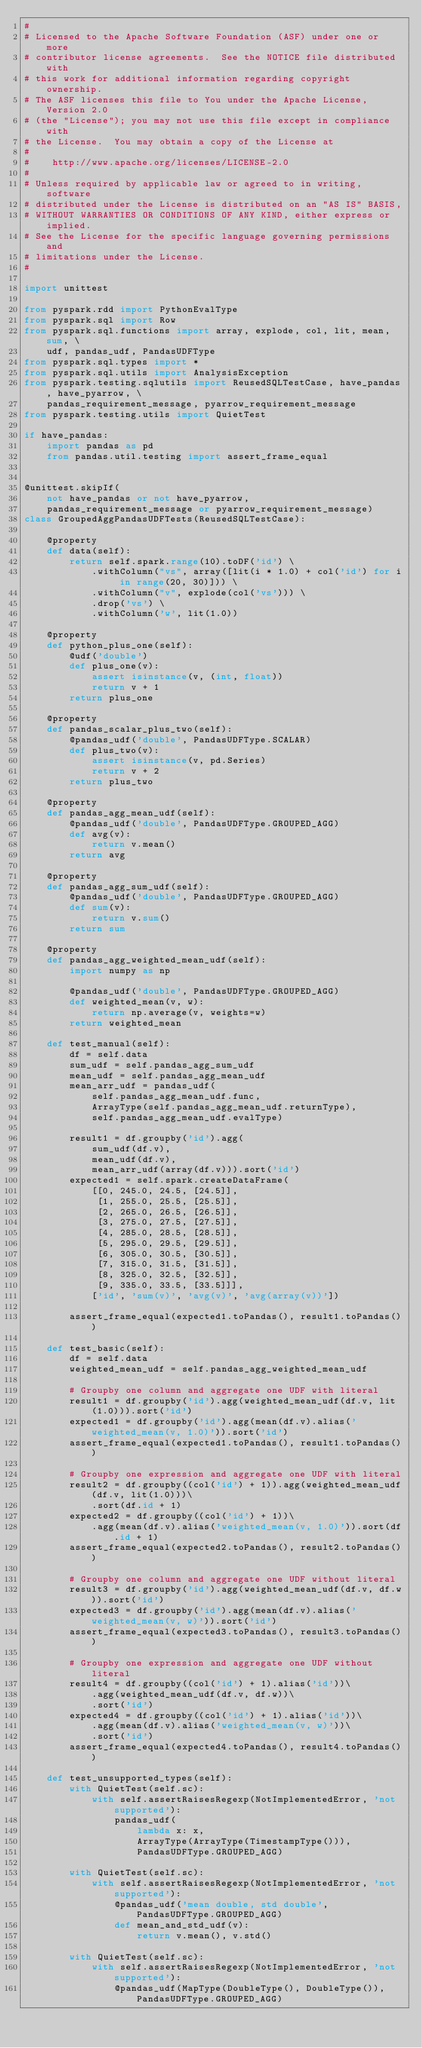Convert code to text. <code><loc_0><loc_0><loc_500><loc_500><_Python_>#
# Licensed to the Apache Software Foundation (ASF) under one or more
# contributor license agreements.  See the NOTICE file distributed with
# this work for additional information regarding copyright ownership.
# The ASF licenses this file to You under the Apache License, Version 2.0
# (the "License"); you may not use this file except in compliance with
# the License.  You may obtain a copy of the License at
#
#    http://www.apache.org/licenses/LICENSE-2.0
#
# Unless required by applicable law or agreed to in writing, software
# distributed under the License is distributed on an "AS IS" BASIS,
# WITHOUT WARRANTIES OR CONDITIONS OF ANY KIND, either express or implied.
# See the License for the specific language governing permissions and
# limitations under the License.
#

import unittest

from pyspark.rdd import PythonEvalType
from pyspark.sql import Row
from pyspark.sql.functions import array, explode, col, lit, mean, sum, \
    udf, pandas_udf, PandasUDFType
from pyspark.sql.types import *
from pyspark.sql.utils import AnalysisException
from pyspark.testing.sqlutils import ReusedSQLTestCase, have_pandas, have_pyarrow, \
    pandas_requirement_message, pyarrow_requirement_message
from pyspark.testing.utils import QuietTest

if have_pandas:
    import pandas as pd
    from pandas.util.testing import assert_frame_equal


@unittest.skipIf(
    not have_pandas or not have_pyarrow,
    pandas_requirement_message or pyarrow_requirement_message)
class GroupedAggPandasUDFTests(ReusedSQLTestCase):

    @property
    def data(self):
        return self.spark.range(10).toDF('id') \
            .withColumn("vs", array([lit(i * 1.0) + col('id') for i in range(20, 30)])) \
            .withColumn("v", explode(col('vs'))) \
            .drop('vs') \
            .withColumn('w', lit(1.0))

    @property
    def python_plus_one(self):
        @udf('double')
        def plus_one(v):
            assert isinstance(v, (int, float))
            return v + 1
        return plus_one

    @property
    def pandas_scalar_plus_two(self):
        @pandas_udf('double', PandasUDFType.SCALAR)
        def plus_two(v):
            assert isinstance(v, pd.Series)
            return v + 2
        return plus_two

    @property
    def pandas_agg_mean_udf(self):
        @pandas_udf('double', PandasUDFType.GROUPED_AGG)
        def avg(v):
            return v.mean()
        return avg

    @property
    def pandas_agg_sum_udf(self):
        @pandas_udf('double', PandasUDFType.GROUPED_AGG)
        def sum(v):
            return v.sum()
        return sum

    @property
    def pandas_agg_weighted_mean_udf(self):
        import numpy as np

        @pandas_udf('double', PandasUDFType.GROUPED_AGG)
        def weighted_mean(v, w):
            return np.average(v, weights=w)
        return weighted_mean

    def test_manual(self):
        df = self.data
        sum_udf = self.pandas_agg_sum_udf
        mean_udf = self.pandas_agg_mean_udf
        mean_arr_udf = pandas_udf(
            self.pandas_agg_mean_udf.func,
            ArrayType(self.pandas_agg_mean_udf.returnType),
            self.pandas_agg_mean_udf.evalType)

        result1 = df.groupby('id').agg(
            sum_udf(df.v),
            mean_udf(df.v),
            mean_arr_udf(array(df.v))).sort('id')
        expected1 = self.spark.createDataFrame(
            [[0, 245.0, 24.5, [24.5]],
             [1, 255.0, 25.5, [25.5]],
             [2, 265.0, 26.5, [26.5]],
             [3, 275.0, 27.5, [27.5]],
             [4, 285.0, 28.5, [28.5]],
             [5, 295.0, 29.5, [29.5]],
             [6, 305.0, 30.5, [30.5]],
             [7, 315.0, 31.5, [31.5]],
             [8, 325.0, 32.5, [32.5]],
             [9, 335.0, 33.5, [33.5]]],
            ['id', 'sum(v)', 'avg(v)', 'avg(array(v))'])

        assert_frame_equal(expected1.toPandas(), result1.toPandas())

    def test_basic(self):
        df = self.data
        weighted_mean_udf = self.pandas_agg_weighted_mean_udf

        # Groupby one column and aggregate one UDF with literal
        result1 = df.groupby('id').agg(weighted_mean_udf(df.v, lit(1.0))).sort('id')
        expected1 = df.groupby('id').agg(mean(df.v).alias('weighted_mean(v, 1.0)')).sort('id')
        assert_frame_equal(expected1.toPandas(), result1.toPandas())

        # Groupby one expression and aggregate one UDF with literal
        result2 = df.groupby((col('id') + 1)).agg(weighted_mean_udf(df.v, lit(1.0)))\
            .sort(df.id + 1)
        expected2 = df.groupby((col('id') + 1))\
            .agg(mean(df.v).alias('weighted_mean(v, 1.0)')).sort(df.id + 1)
        assert_frame_equal(expected2.toPandas(), result2.toPandas())

        # Groupby one column and aggregate one UDF without literal
        result3 = df.groupby('id').agg(weighted_mean_udf(df.v, df.w)).sort('id')
        expected3 = df.groupby('id').agg(mean(df.v).alias('weighted_mean(v, w)')).sort('id')
        assert_frame_equal(expected3.toPandas(), result3.toPandas())

        # Groupby one expression and aggregate one UDF without literal
        result4 = df.groupby((col('id') + 1).alias('id'))\
            .agg(weighted_mean_udf(df.v, df.w))\
            .sort('id')
        expected4 = df.groupby((col('id') + 1).alias('id'))\
            .agg(mean(df.v).alias('weighted_mean(v, w)'))\
            .sort('id')
        assert_frame_equal(expected4.toPandas(), result4.toPandas())

    def test_unsupported_types(self):
        with QuietTest(self.sc):
            with self.assertRaisesRegexp(NotImplementedError, 'not supported'):
                pandas_udf(
                    lambda x: x,
                    ArrayType(ArrayType(TimestampType())),
                    PandasUDFType.GROUPED_AGG)

        with QuietTest(self.sc):
            with self.assertRaisesRegexp(NotImplementedError, 'not supported'):
                @pandas_udf('mean double, std double', PandasUDFType.GROUPED_AGG)
                def mean_and_std_udf(v):
                    return v.mean(), v.std()

        with QuietTest(self.sc):
            with self.assertRaisesRegexp(NotImplementedError, 'not supported'):
                @pandas_udf(MapType(DoubleType(), DoubleType()), PandasUDFType.GROUPED_AGG)</code> 